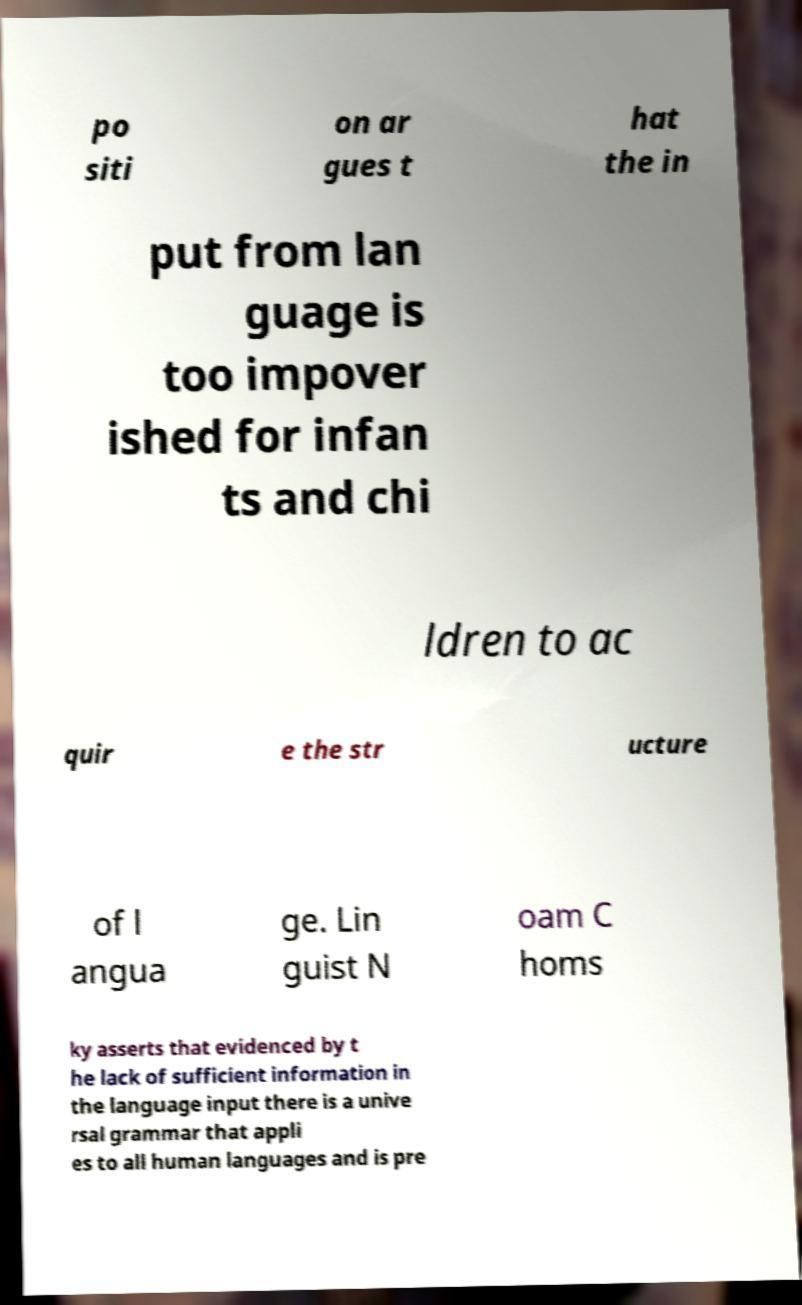Please identify and transcribe the text found in this image. po siti on ar gues t hat the in put from lan guage is too impover ished for infan ts and chi ldren to ac quir e the str ucture of l angua ge. Lin guist N oam C homs ky asserts that evidenced by t he lack of sufficient information in the language input there is a unive rsal grammar that appli es to all human languages and is pre 